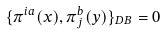Convert formula to latex. <formula><loc_0><loc_0><loc_500><loc_500>\{ \pi ^ { i a } ( x ) , \pi _ { j } ^ { b } ( y ) \} _ { D B } = 0</formula> 